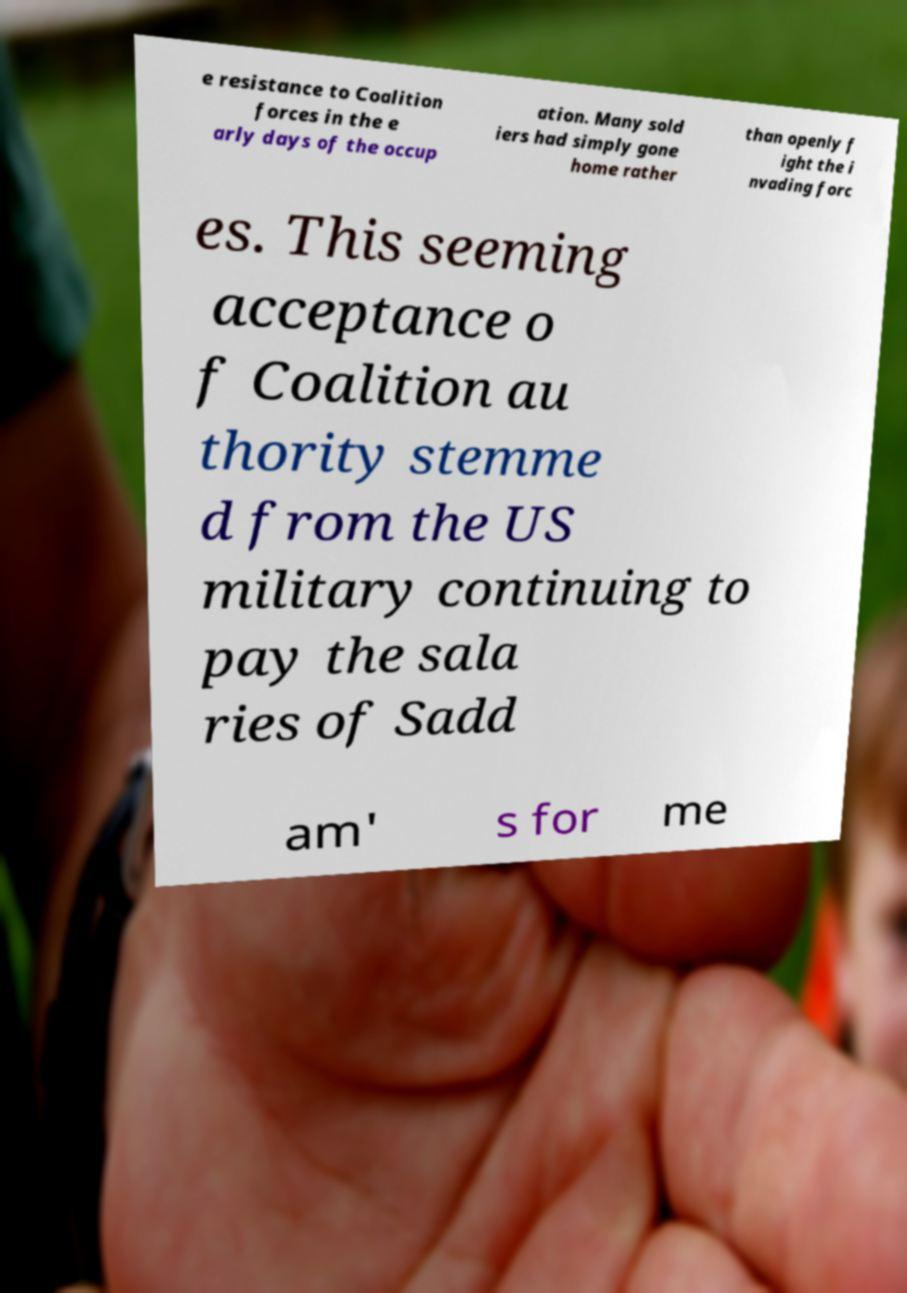Can you accurately transcribe the text from the provided image for me? e resistance to Coalition forces in the e arly days of the occup ation. Many sold iers had simply gone home rather than openly f ight the i nvading forc es. This seeming acceptance o f Coalition au thority stemme d from the US military continuing to pay the sala ries of Sadd am' s for me 